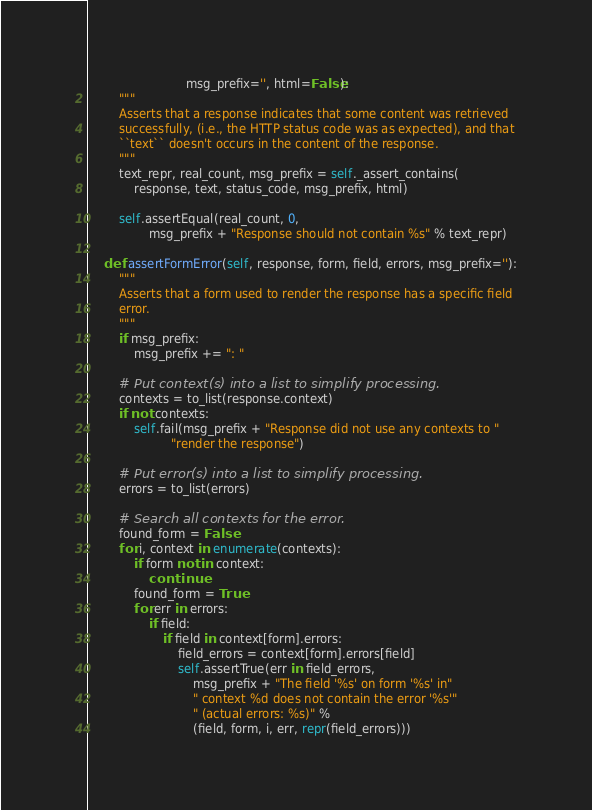Convert code to text. <code><loc_0><loc_0><loc_500><loc_500><_Python_>                          msg_prefix='', html=False):
        """
        Asserts that a response indicates that some content was retrieved
        successfully, (i.e., the HTTP status code was as expected), and that
        ``text`` doesn't occurs in the content of the response.
        """
        text_repr, real_count, msg_prefix = self._assert_contains(
            response, text, status_code, msg_prefix, html)

        self.assertEqual(real_count, 0,
                msg_prefix + "Response should not contain %s" % text_repr)

    def assertFormError(self, response, form, field, errors, msg_prefix=''):
        """
        Asserts that a form used to render the response has a specific field
        error.
        """
        if msg_prefix:
            msg_prefix += ": "

        # Put context(s) into a list to simplify processing.
        contexts = to_list(response.context)
        if not contexts:
            self.fail(msg_prefix + "Response did not use any contexts to "
                      "render the response")

        # Put error(s) into a list to simplify processing.
        errors = to_list(errors)

        # Search all contexts for the error.
        found_form = False
        for i, context in enumerate(contexts):
            if form not in context:
                continue
            found_form = True
            for err in errors:
                if field:
                    if field in context[form].errors:
                        field_errors = context[form].errors[field]
                        self.assertTrue(err in field_errors,
                            msg_prefix + "The field '%s' on form '%s' in"
                            " context %d does not contain the error '%s'"
                            " (actual errors: %s)" %
                            (field, form, i, err, repr(field_errors)))</code> 